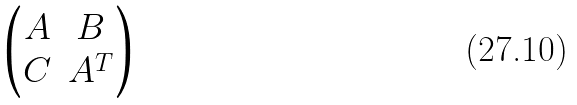Convert formula to latex. <formula><loc_0><loc_0><loc_500><loc_500>\begin{pmatrix} A & B \\ C & A ^ { T } \end{pmatrix}</formula> 